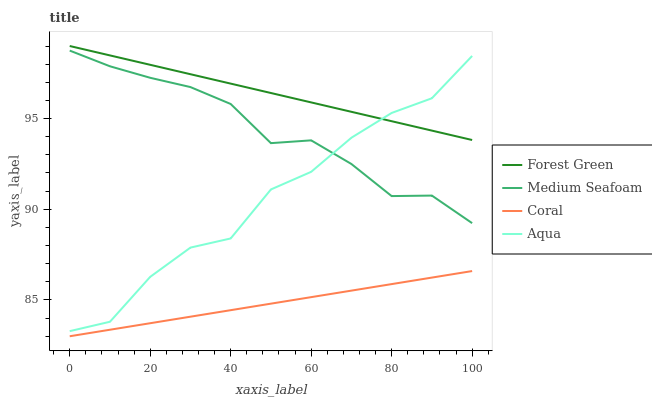Does Coral have the minimum area under the curve?
Answer yes or no. Yes. Does Forest Green have the maximum area under the curve?
Answer yes or no. Yes. Does Aqua have the minimum area under the curve?
Answer yes or no. No. Does Aqua have the maximum area under the curve?
Answer yes or no. No. Is Coral the smoothest?
Answer yes or no. Yes. Is Aqua the roughest?
Answer yes or no. Yes. Is Forest Green the smoothest?
Answer yes or no. No. Is Forest Green the roughest?
Answer yes or no. No. Does Aqua have the lowest value?
Answer yes or no. No. Does Forest Green have the highest value?
Answer yes or no. Yes. Does Aqua have the highest value?
Answer yes or no. No. Is Medium Seafoam less than Forest Green?
Answer yes or no. Yes. Is Forest Green greater than Medium Seafoam?
Answer yes or no. Yes. Does Aqua intersect Forest Green?
Answer yes or no. Yes. Is Aqua less than Forest Green?
Answer yes or no. No. Is Aqua greater than Forest Green?
Answer yes or no. No. Does Medium Seafoam intersect Forest Green?
Answer yes or no. No. 